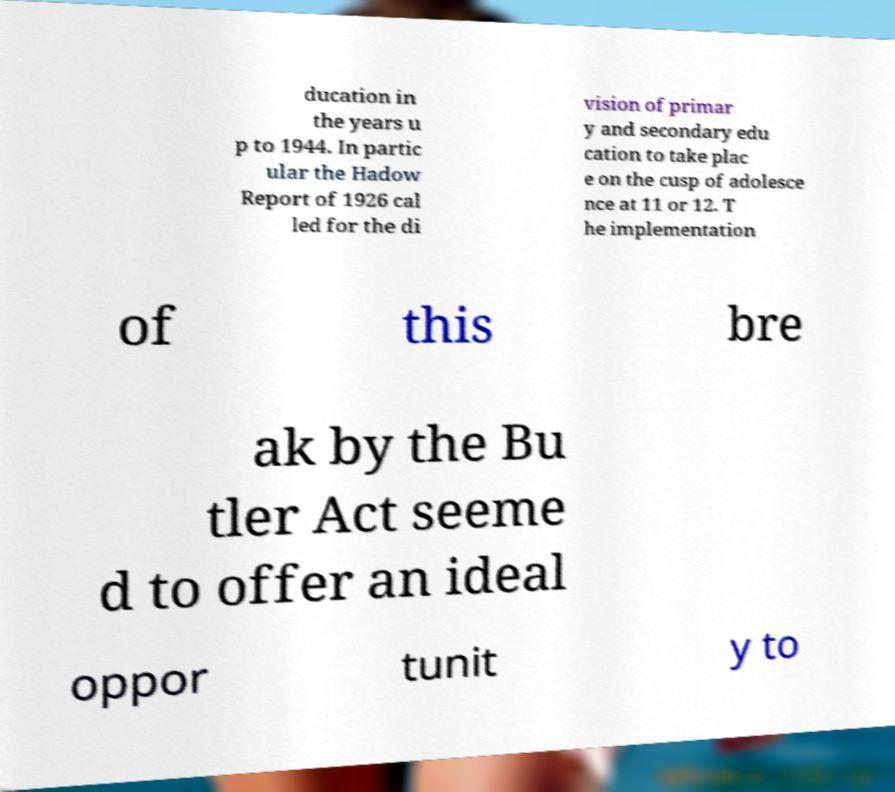There's text embedded in this image that I need extracted. Can you transcribe it verbatim? ducation in the years u p to 1944. In partic ular the Hadow Report of 1926 cal led for the di vision of primar y and secondary edu cation to take plac e on the cusp of adolesce nce at 11 or 12. T he implementation of this bre ak by the Bu tler Act seeme d to offer an ideal oppor tunit y to 